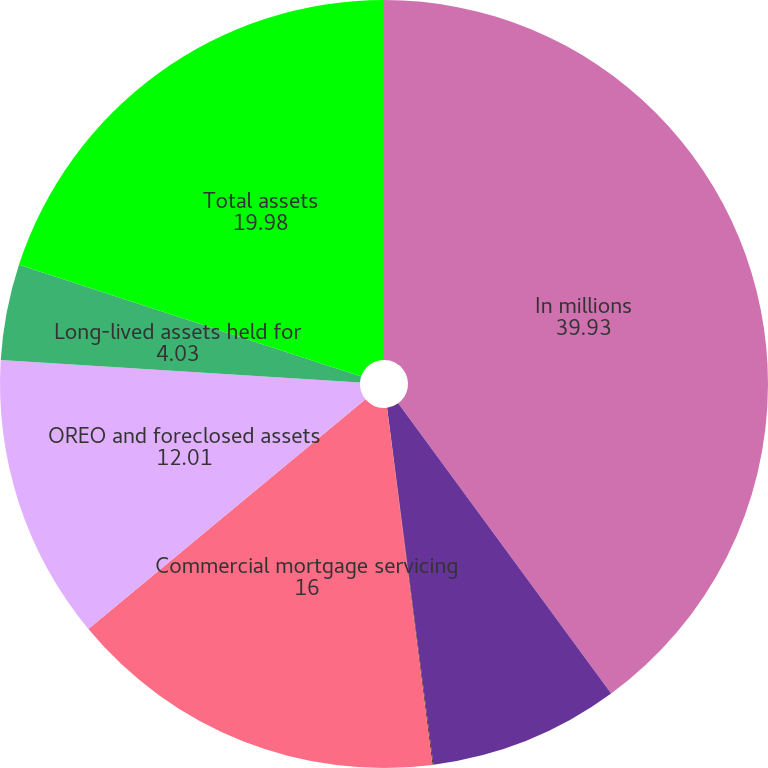Convert chart. <chart><loc_0><loc_0><loc_500><loc_500><pie_chart><fcel>In millions<fcel>Nonaccrual loans<fcel>Loans held for sale<fcel>Commercial mortgage servicing<fcel>OREO and foreclosed assets<fcel>Long-lived assets held for<fcel>Total assets<nl><fcel>39.93%<fcel>8.02%<fcel>0.04%<fcel>16.0%<fcel>12.01%<fcel>4.03%<fcel>19.98%<nl></chart> 